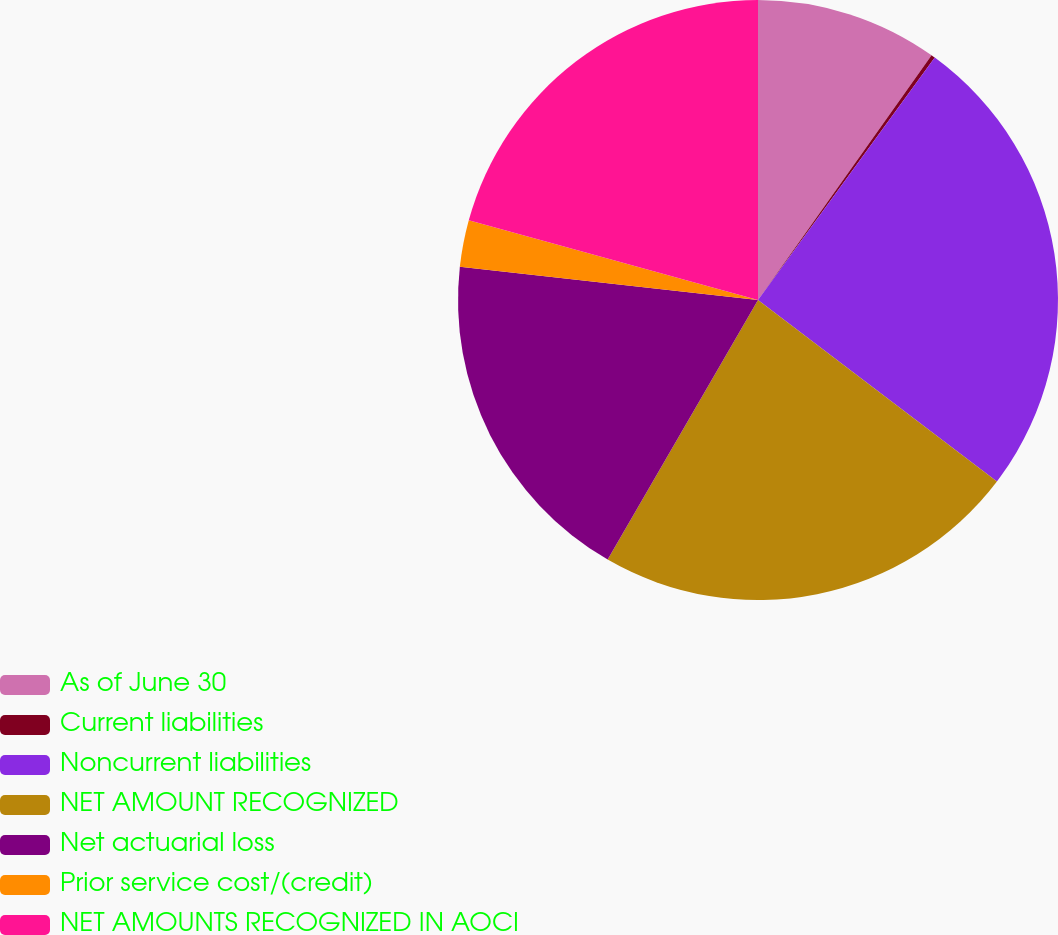Convert chart. <chart><loc_0><loc_0><loc_500><loc_500><pie_chart><fcel>As of June 30<fcel>Current liabilities<fcel>Noncurrent liabilities<fcel>NET AMOUNT RECOGNIZED<fcel>Net actuarial loss<fcel>Prior service cost/(credit)<fcel>NET AMOUNTS RECOGNIZED IN AOCI<nl><fcel>9.82%<fcel>0.21%<fcel>25.31%<fcel>23.02%<fcel>18.42%<fcel>2.51%<fcel>20.72%<nl></chart> 